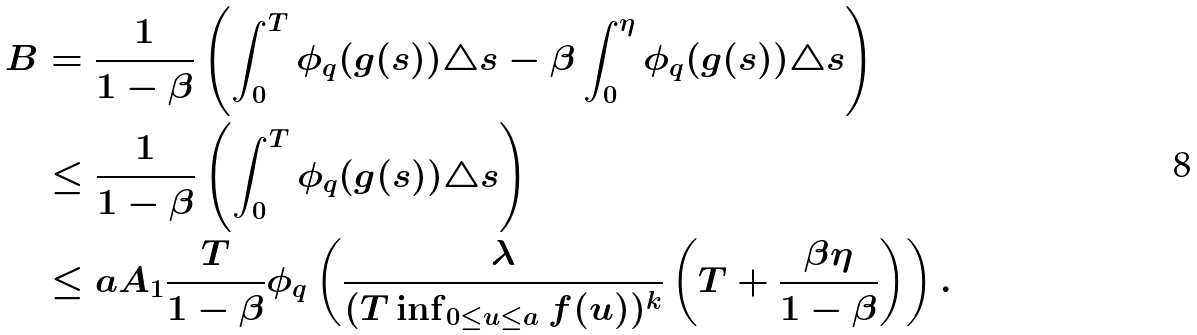Convert formula to latex. <formula><loc_0><loc_0><loc_500><loc_500>B & = \frac { 1 } { 1 - \beta } \left ( \int _ { 0 } ^ { T } \phi _ { q } ( g ( s ) ) \triangle s - \beta \int _ { 0 } ^ { \eta } \phi _ { q } ( g ( s ) ) \triangle s \right ) \\ & \leq \frac { 1 } { 1 - \beta } \left ( \int _ { 0 } ^ { T } \phi _ { q } ( g ( s ) ) \triangle s \right ) \\ & \leq a A _ { 1 } \frac { T } { 1 - \beta } \phi _ { q } \left ( \frac { \lambda } { ( T \inf _ { 0 \leq u \leq a } f ( u ) ) ^ { k } } \left ( T + \frac { \beta \eta } { 1 - \beta } \right ) \right ) .</formula> 